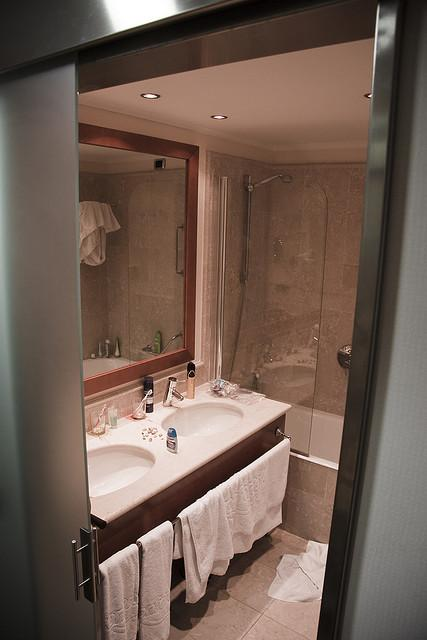How many people probably use this room?

Choices:
A) five
B) four
C) two
D) three two 